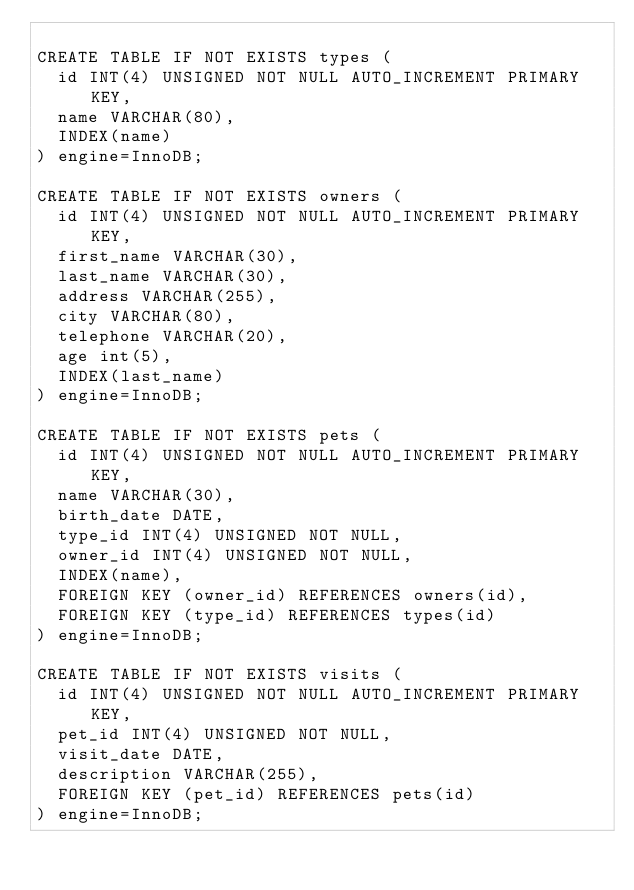Convert code to text. <code><loc_0><loc_0><loc_500><loc_500><_SQL_>
CREATE TABLE IF NOT EXISTS types (
  id INT(4) UNSIGNED NOT NULL AUTO_INCREMENT PRIMARY KEY,
  name VARCHAR(80),
  INDEX(name)
) engine=InnoDB;

CREATE TABLE IF NOT EXISTS owners (
  id INT(4) UNSIGNED NOT NULL AUTO_INCREMENT PRIMARY KEY,
  first_name VARCHAR(30),
  last_name VARCHAR(30),
  address VARCHAR(255),
  city VARCHAR(80),
  telephone VARCHAR(20),
  age int(5),
  INDEX(last_name)
) engine=InnoDB;

CREATE TABLE IF NOT EXISTS pets (
  id INT(4) UNSIGNED NOT NULL AUTO_INCREMENT PRIMARY KEY,
  name VARCHAR(30),
  birth_date DATE,
  type_id INT(4) UNSIGNED NOT NULL,
  owner_id INT(4) UNSIGNED NOT NULL,
  INDEX(name),
  FOREIGN KEY (owner_id) REFERENCES owners(id),
  FOREIGN KEY (type_id) REFERENCES types(id)
) engine=InnoDB;

CREATE TABLE IF NOT EXISTS visits (
  id INT(4) UNSIGNED NOT NULL AUTO_INCREMENT PRIMARY KEY,
  pet_id INT(4) UNSIGNED NOT NULL,
  visit_date DATE,
  description VARCHAR(255),
  FOREIGN KEY (pet_id) REFERENCES pets(id)
) engine=InnoDB;
</code> 